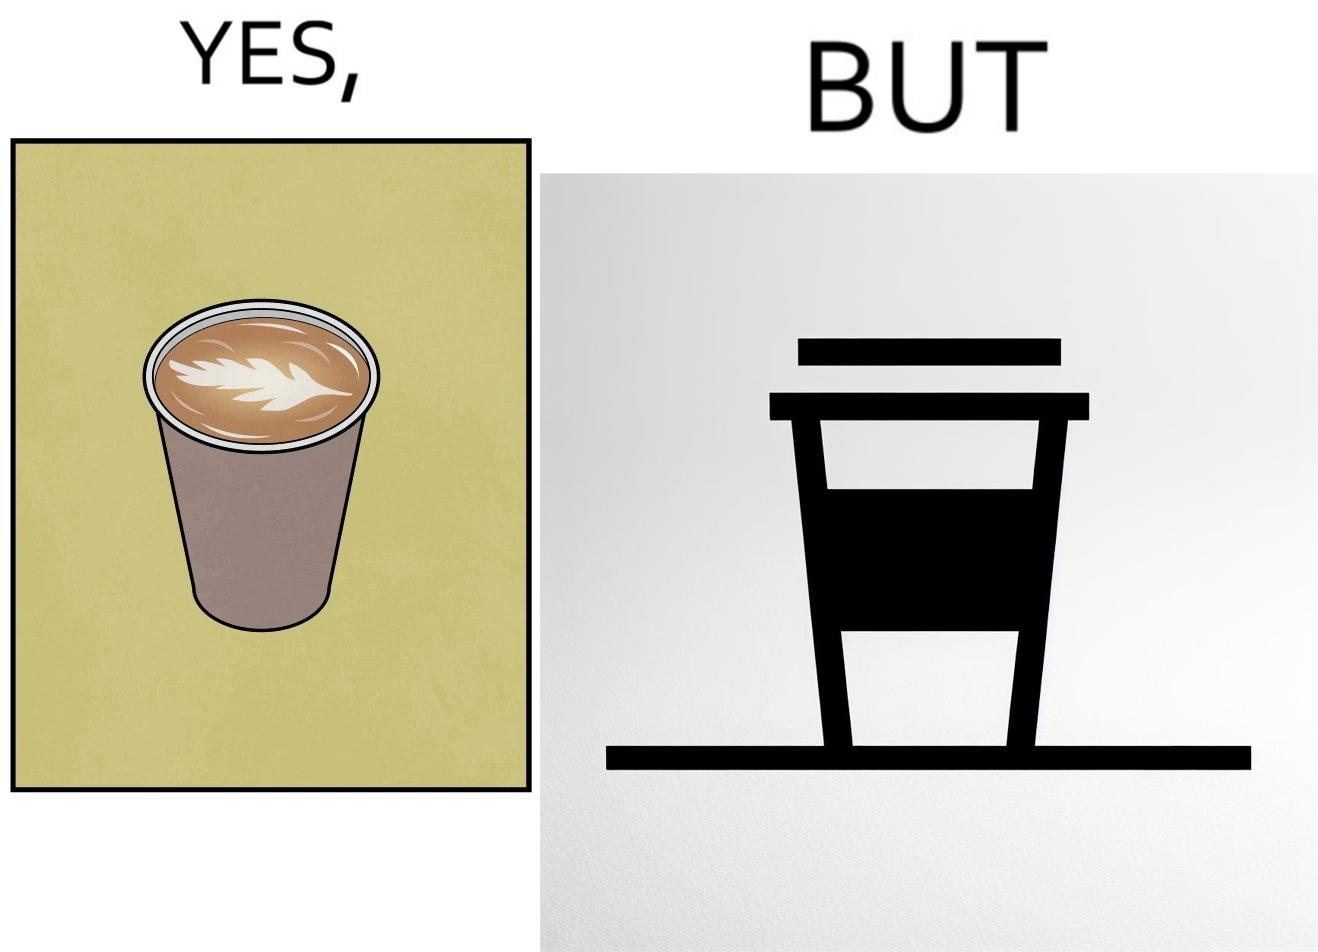What is shown in this image? The images are funny since it shows how someone has put effort into a cup of coffee to do latte art on it only for it to be invisible after a lid is put on the coffee cup before serving to a customer 